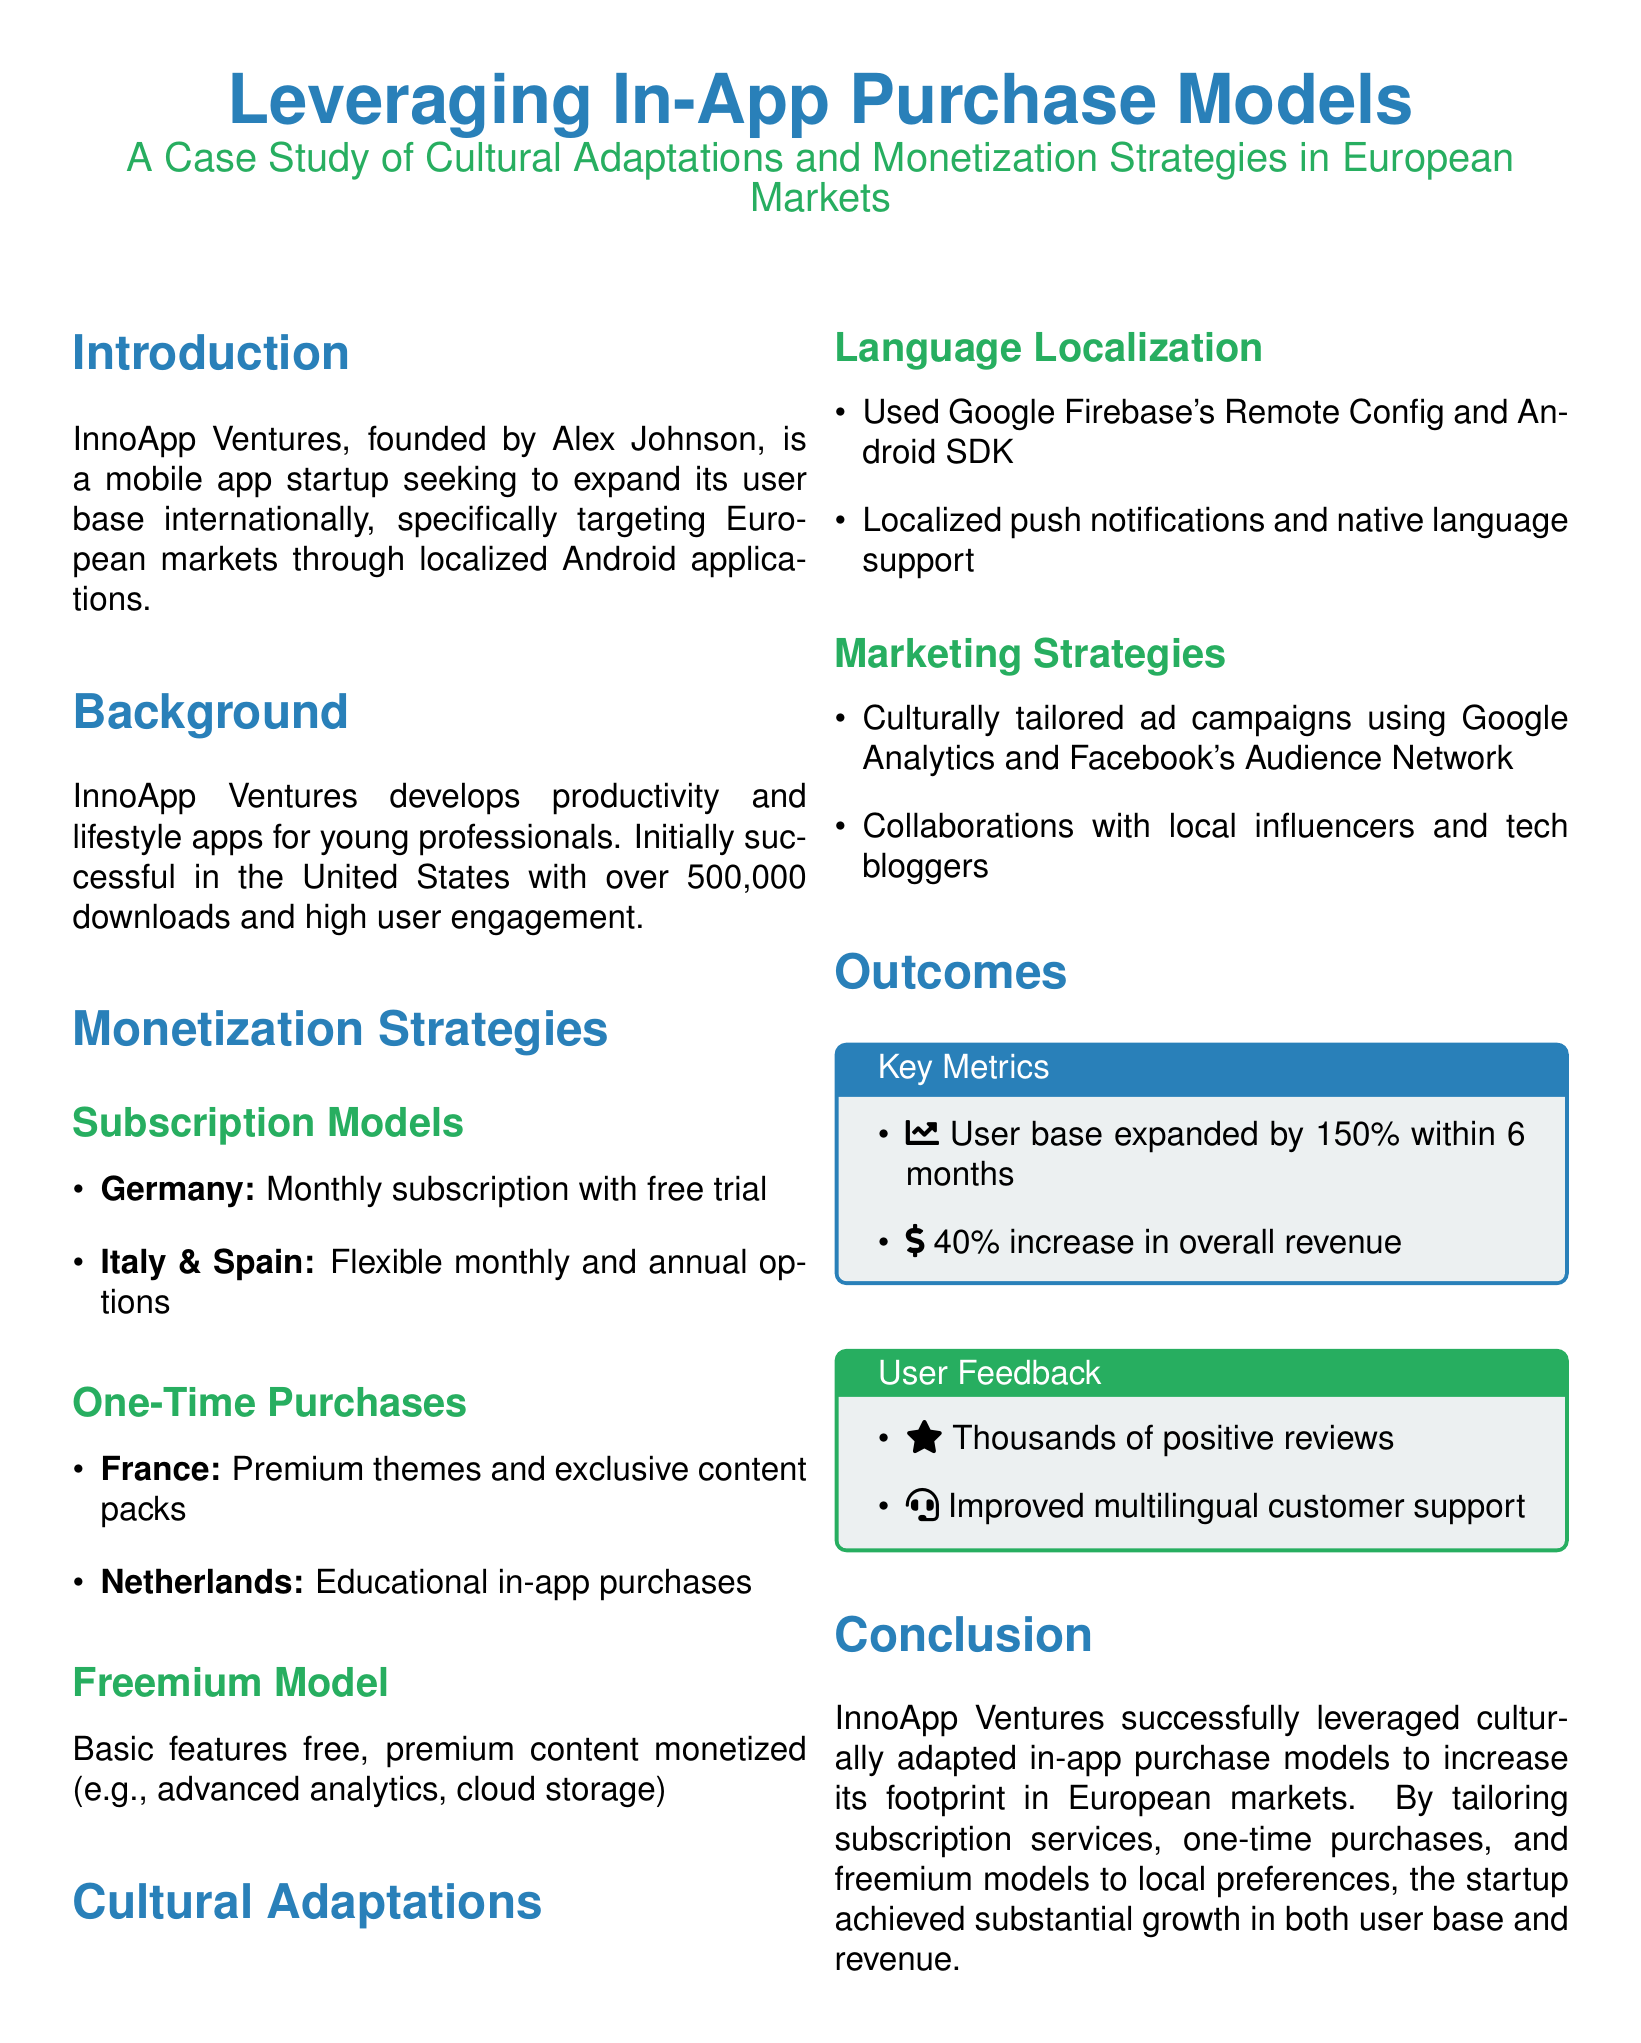What is the name of the startup? The name of the startup is mentioned in the introduction of the document as InnoApp Ventures.
Answer: InnoApp Ventures Who is the founder of InnoApp Ventures? The founder of InnoApp Ventures, as stated in the document, is Alex Johnson.
Answer: Alex Johnson How much did the user base expand within 6 months? The document indicates that the user base expanded by 150% within 6 months.
Answer: 150% What monetization model is used in Germany? The document states that a monthly subscription with a free trial is the monetization model used in Germany.
Answer: Monthly subscription with free trial Which two countries use flexible options for subscriptions? The document mentions that Italy and Spain use flexible monthly and annual options for subscriptions.
Answer: Italy & Spain What feedback aspect is mentioned from users? The user feedback section in the document highlights improvement in multilingual customer support.
Answer: Improved multilingual customer support What cultural adaptation was used for notifications? The document states that localized push notifications were used as a cultural adaptation.
Answer: Localized push notifications What is a key outcome concerning revenue? According to the document, there was a 40% increase in overall revenue noted as a key outcome.
Answer: 40% increase in overall revenue What marketing strategy involved local influencers? The document notes that collaborations with local influencers and tech bloggers were part of the marketing strategies.
Answer: Collaborations with local influencers and tech bloggers 